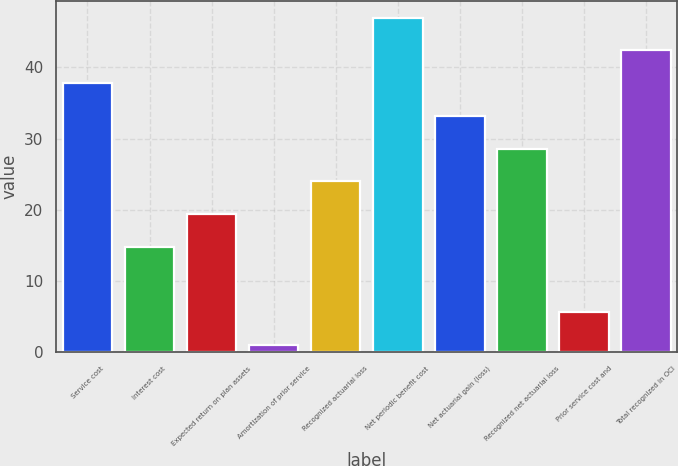Convert chart to OTSL. <chart><loc_0><loc_0><loc_500><loc_500><bar_chart><fcel>Service cost<fcel>Interest cost<fcel>Expected return on plan assets<fcel>Amortization of prior service<fcel>Recognized actuarial loss<fcel>Net periodic benefit cost<fcel>Net actuarial gain (loss)<fcel>Recognized net actuarial loss<fcel>Prior service cost and<fcel>Total recognized in OCI<nl><fcel>37.8<fcel>14.8<fcel>19.4<fcel>1<fcel>24<fcel>47<fcel>33.2<fcel>28.6<fcel>5.6<fcel>42.4<nl></chart> 